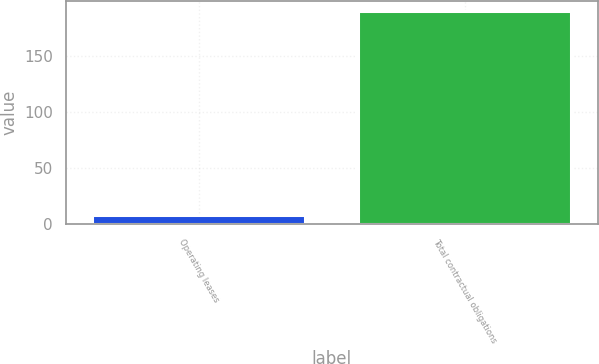Convert chart to OTSL. <chart><loc_0><loc_0><loc_500><loc_500><bar_chart><fcel>Operating leases<fcel>Total contractual obligations<nl><fcel>8.3<fcel>190<nl></chart> 